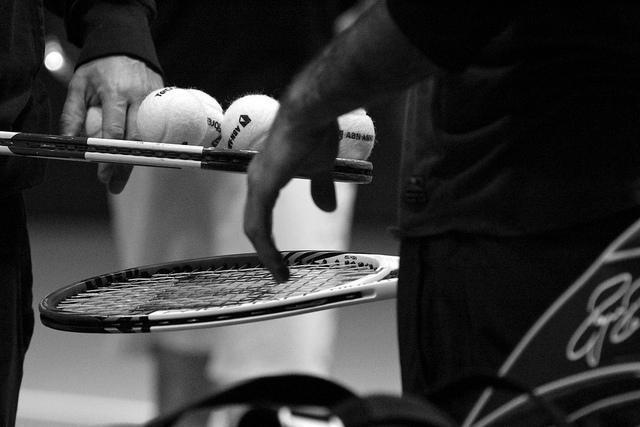How many balls in this picture?
Give a very brief answer. 5. How many sports balls are there?
Give a very brief answer. 2. How many tennis rackets can be seen?
Give a very brief answer. 2. How many people can you see?
Give a very brief answer. 2. How many animals have a bird on their back?
Give a very brief answer. 0. 